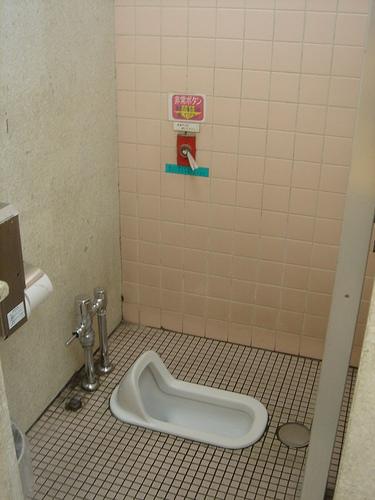Is there toilet paper in this bathroom?
Answer briefly. Yes. Does the floor look nasty and dirty?
Be succinct. Yes. What color is the horizontal rectangle on the back wall?
Be succinct. Blue. Is this toilet designed for a man or a woman?
Short answer required. Man. 